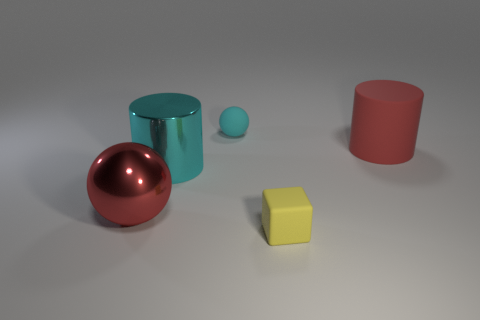Add 1 small cyan objects. How many objects exist? 6 Subtract all blocks. How many objects are left? 4 Subtract 1 cyan cylinders. How many objects are left? 4 Subtract all large gray rubber cylinders. Subtract all big metal balls. How many objects are left? 4 Add 2 tiny cyan matte things. How many tiny cyan matte things are left? 3 Add 5 large metallic cylinders. How many large metallic cylinders exist? 6 